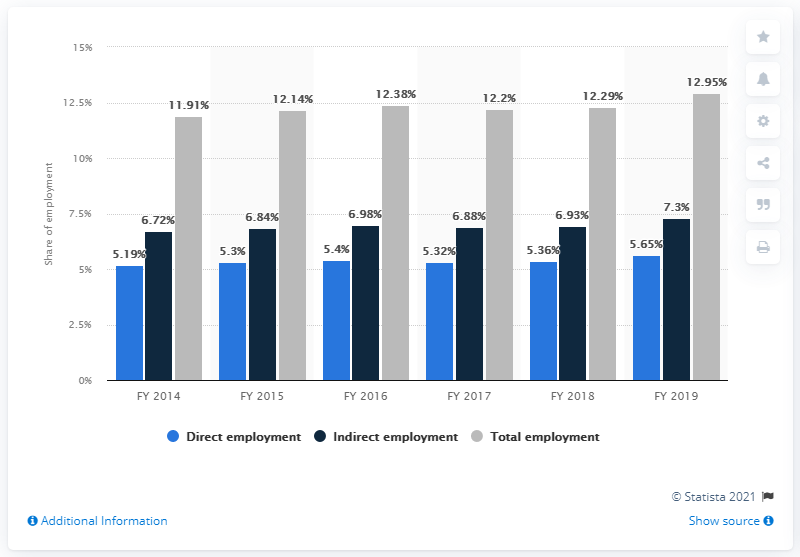Draw attention to some important aspects in this diagram. In 2014, India's tourism industry experienced a significant increase of 12.95%. This increase can be attributed to a variety of factors, including the increasing popularity of tourism in India, the growth of the economy, and improvements in infrastructure and transportation. In 2019, the tourism industry contributed approximately 12.95% of India's total employment. 